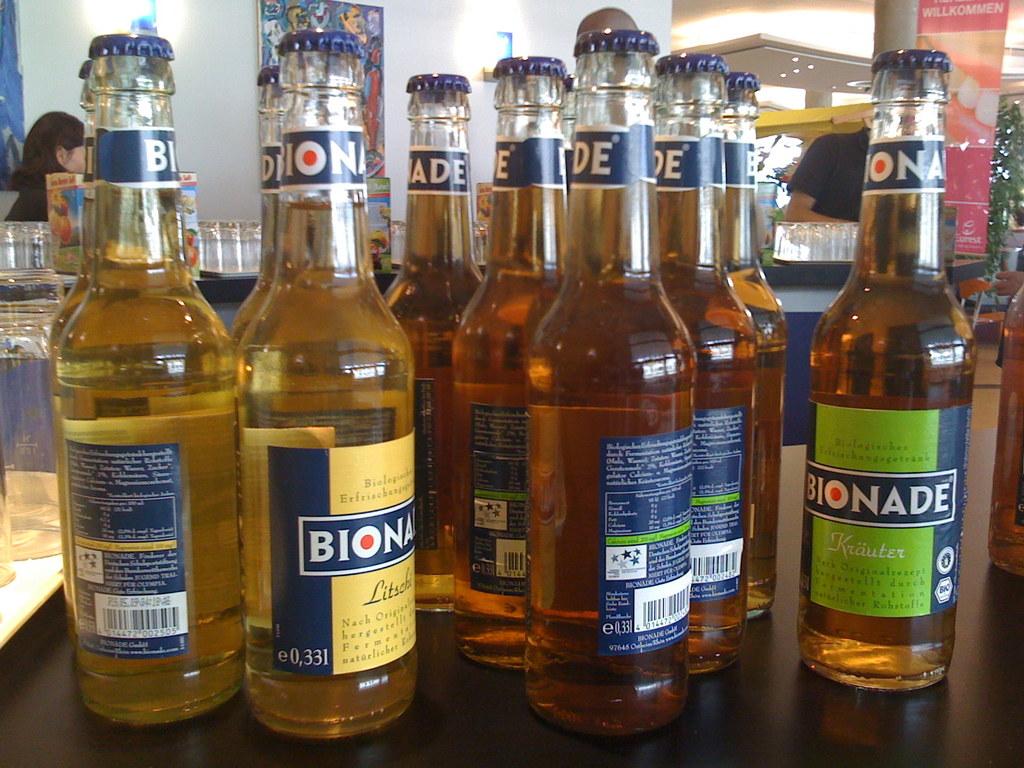What brand are these products?
Offer a terse response. Bionade. 